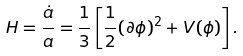Convert formula to latex. <formula><loc_0><loc_0><loc_500><loc_500>H = \frac { \dot { a } } { a } = \frac { 1 } { 3 } \left [ \frac { 1 } { 2 } ( \partial \phi ) ^ { 2 } + V ( \phi ) \right ] .</formula> 